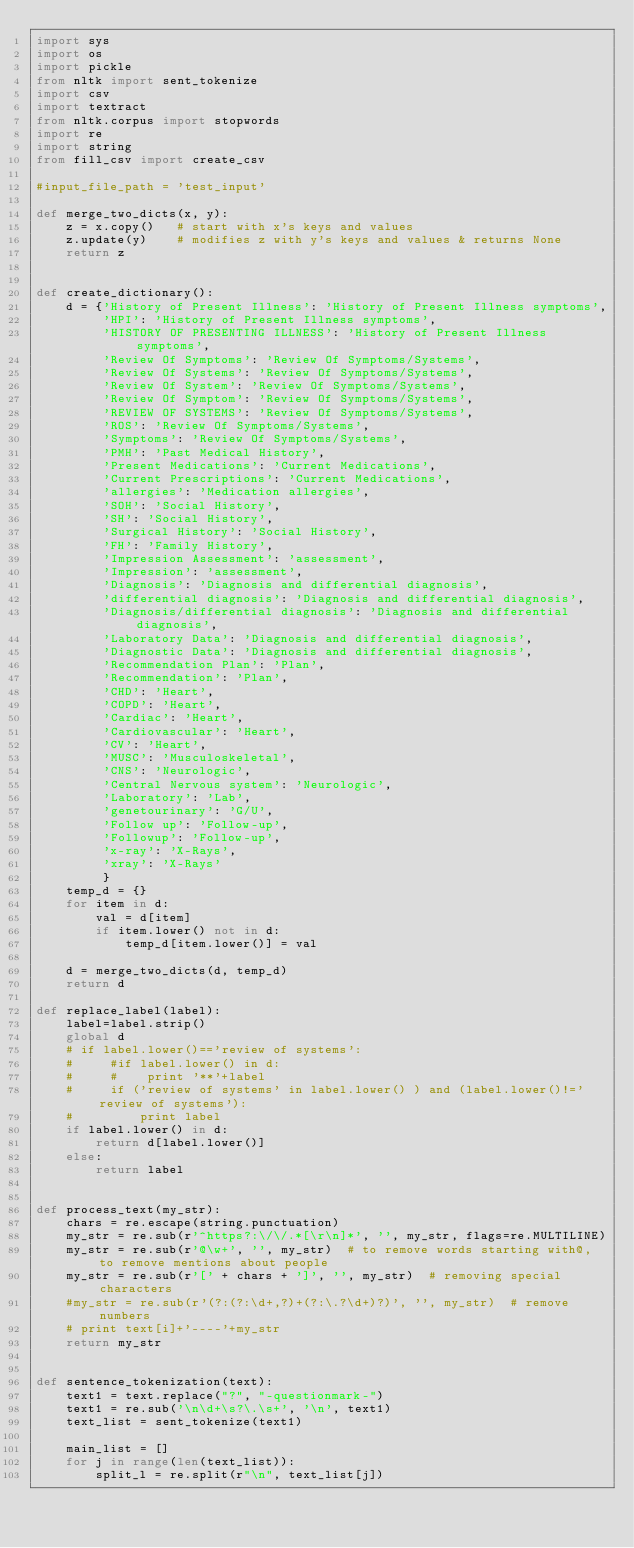Convert code to text. <code><loc_0><loc_0><loc_500><loc_500><_Python_>import sys
import os
import pickle
from nltk import sent_tokenize
import csv
import textract
from nltk.corpus import stopwords
import re
import string
from fill_csv import create_csv

#input_file_path = 'test_input'

def merge_two_dicts(x, y):
    z = x.copy()   # start with x's keys and values
    z.update(y)    # modifies z with y's keys and values & returns None
    return z


def create_dictionary():
    d = {'History of Present Illness': 'History of Present Illness symptoms',
         'HPI': 'History of Present Illness symptoms',
         'HISTORY OF PRESENTING ILLNESS': 'History of Present Illness symptoms',
         'Review Of Symptoms': 'Review Of Symptoms/Systems',
         'Review Of Systems': 'Review Of Symptoms/Systems',
         'Review Of System': 'Review Of Symptoms/Systems',
         'Review Of Symptom': 'Review Of Symptoms/Systems',
         'REVIEW OF SYSTEMS': 'Review Of Symptoms/Systems',
         'ROS': 'Review Of Symptoms/Systems',
         'Symptoms': 'Review Of Symptoms/Systems',
         'PMH': 'Past Medical History',
         'Present Medications': 'Current Medications',
         'Current Prescriptions': 'Current Medications',
         'allergies': 'Medication allergies',
         'SOH': 'Social History',
         'SH': 'Social History',
         'Surgical History': 'Social History',
         'FH': 'Family History',
         'Impression Assessment': 'assessment',
         'Impression': 'assessment',
         'Diagnosis': 'Diagnosis and differential diagnosis',
         'differential diagnosis': 'Diagnosis and differential diagnosis',
         'Diagnosis/differential diagnosis': 'Diagnosis and differential diagnosis',
         'Laboratory Data': 'Diagnosis and differential diagnosis',
         'Diagnostic Data': 'Diagnosis and differential diagnosis',
         'Recommendation Plan': 'Plan',
         'Recommendation': 'Plan',
         'CHD': 'Heart',
         'COPD': 'Heart',
         'Cardiac': 'Heart',
         'Cardiovascular': 'Heart',
         'CV': 'Heart',
         'MUSC': 'Musculoskeletal',
         'CNS': 'Neurologic',
         'Central Nervous system': 'Neurologic',
         'Laboratory': 'Lab',
         'genetourinary': 'G/U',
         'Follow up': 'Follow-up',
         'Followup': 'Follow-up',
         'x-ray': 'X-Rays',
         'xray': 'X-Rays'
         }
    temp_d = {}
    for item in d:
        val = d[item]
        if item.lower() not in d:
            temp_d[item.lower()] = val

    d = merge_two_dicts(d, temp_d)
    return d

def replace_label(label):
    label=label.strip()
    global d
    # if label.lower()=='review of systems':
    #     #if label.lower() in d:
    #     #    print '**'+label
    #     if ('review of systems' in label.lower() ) and (label.lower()!='review of systems'):
    #         print label
    if label.lower() in d:
        return d[label.lower()]
    else:
        return label


def process_text(my_str):
    chars = re.escape(string.punctuation)
    my_str = re.sub(r'^https?:\/\/.*[\r\n]*', '', my_str, flags=re.MULTILINE)
    my_str = re.sub(r'@\w+', '', my_str)  # to remove words starting with@, to remove mentions about people
    my_str = re.sub(r'[' + chars + ']', '', my_str)  # removing special characters
    #my_str = re.sub(r'(?:(?:\d+,?)+(?:\.?\d+)?)', '', my_str)  # remove numbers
    # print text[i]+'----'+my_str
    return my_str


def sentence_tokenization(text):
    text1 = text.replace("?", "-questionmark-")
    text1 = re.sub('\n\d+\s?\.\s+', '\n', text1)
    text_list = sent_tokenize(text1)

    main_list = []
    for j in range(len(text_list)):
        split_l = re.split(r"\n", text_list[j])</code> 